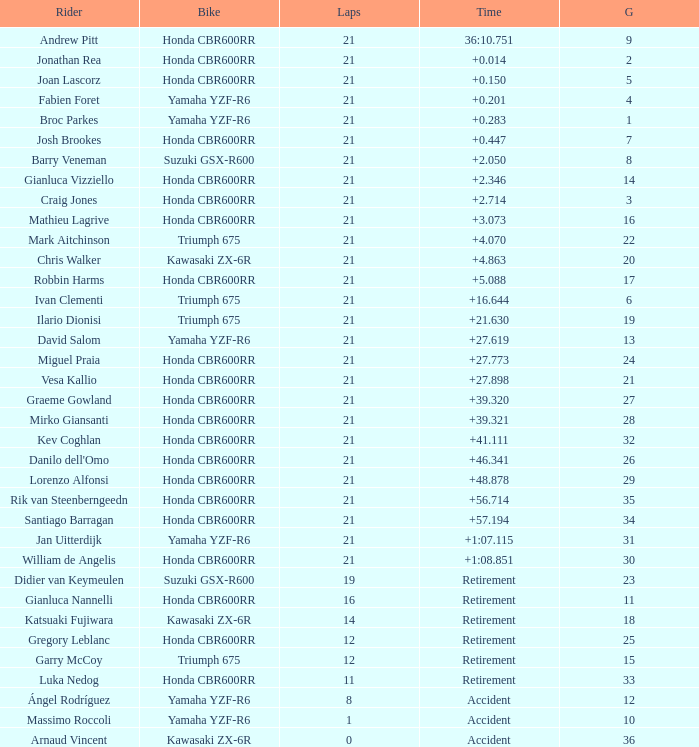088? None. 